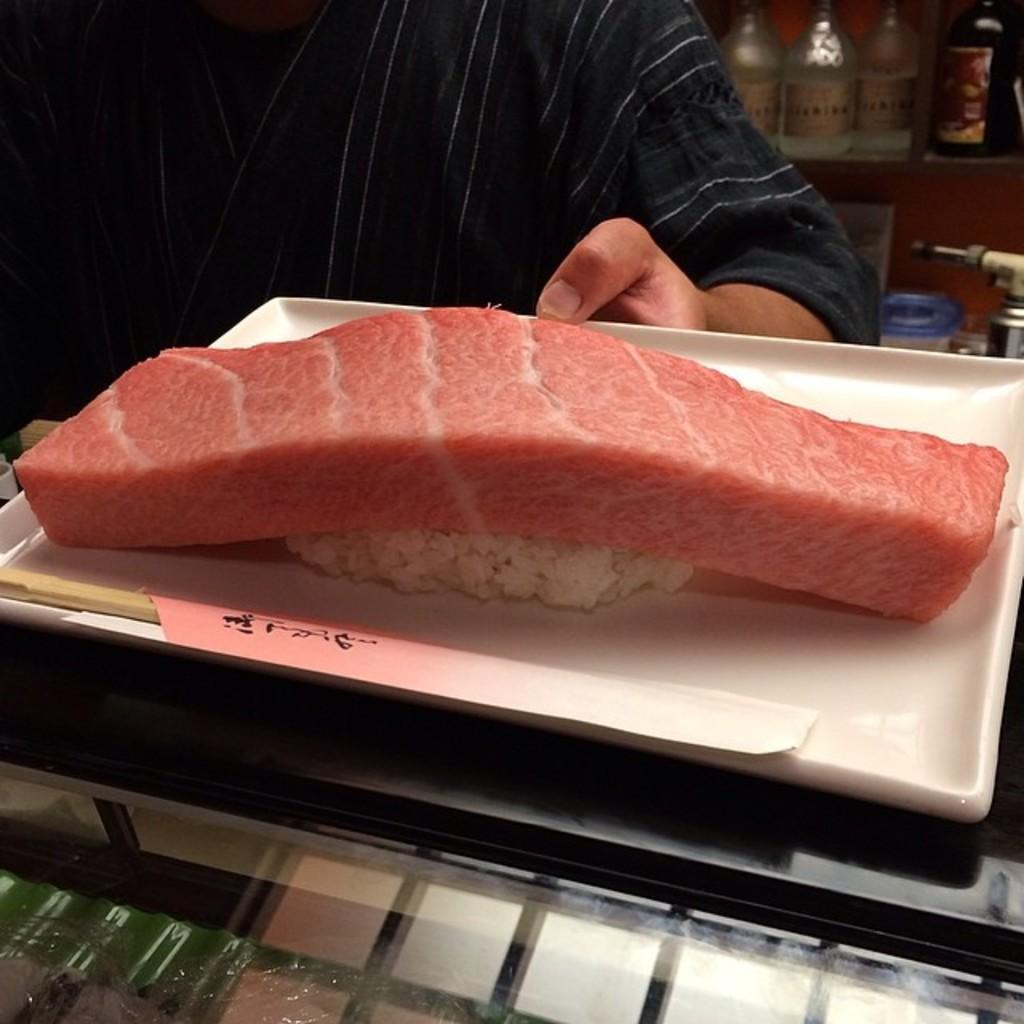What is on the tray that is visible in the image? There is meat on a tray in the image. Where is the tray located in the image? The tray is placed on a table. Who is in front of the tray in the image? There is a person in front of the tray. What can be seen behind the person in the image? There are bottles visible behind the person, and there are objects in a rack behind the person. What type of leather is being used to cover the poison in the image? There is no leather or poison present in the image. 